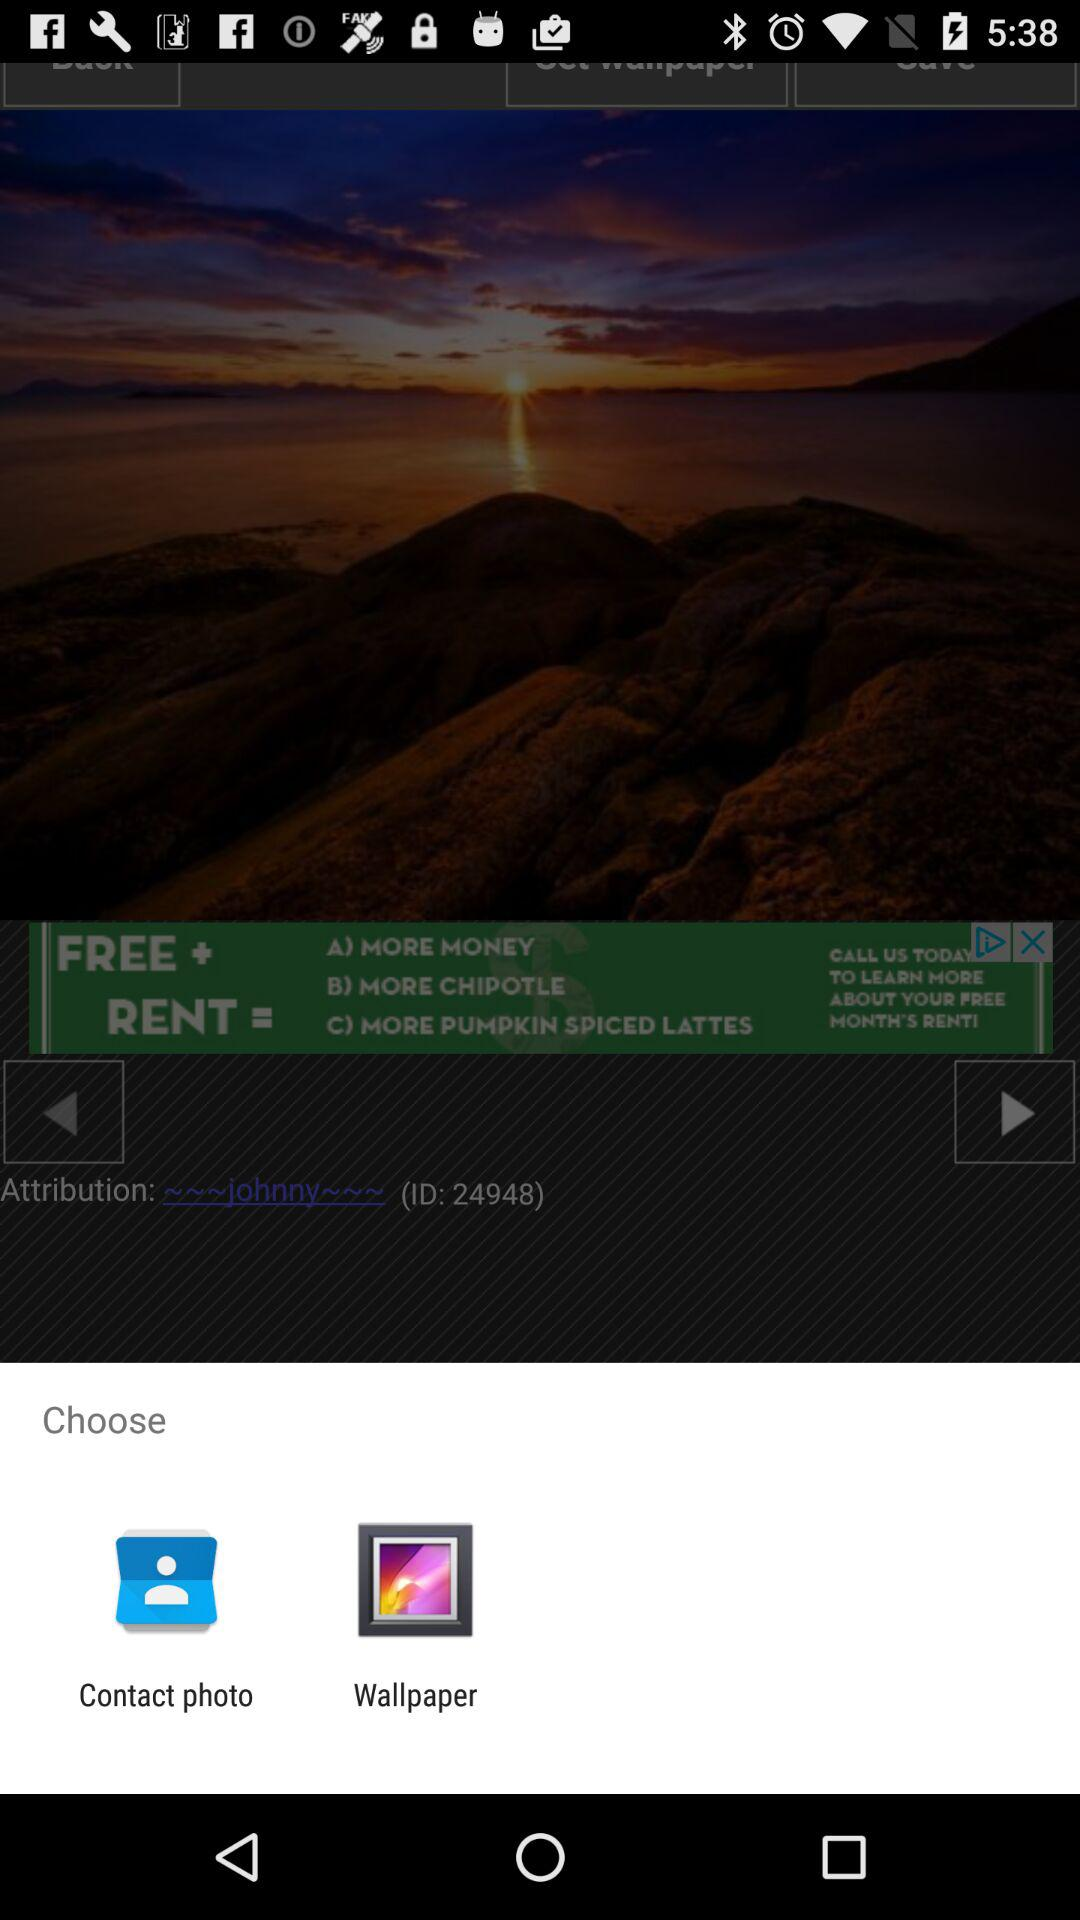Which applications can I use to share? You can use "Contact photo" and "Wallpaper". 